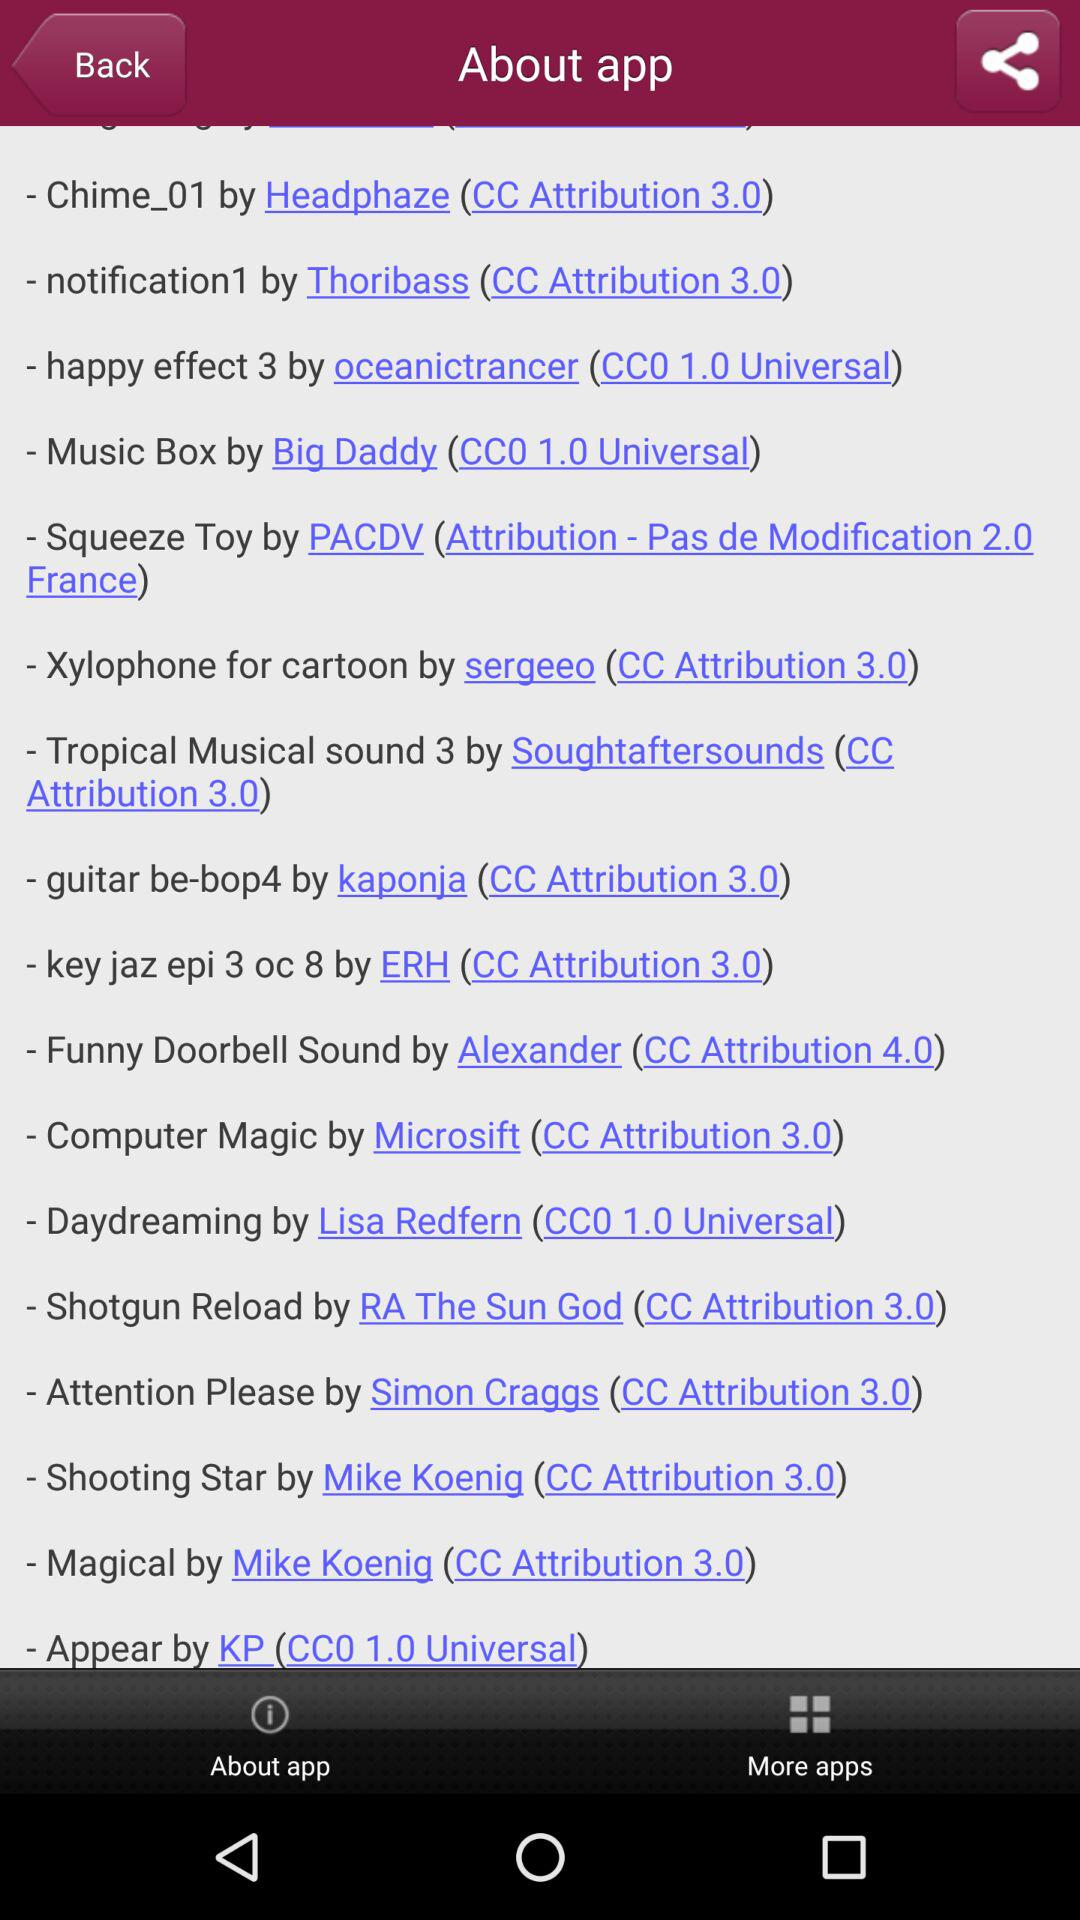Who created "Magical"? "Magical" was created by Mike Koenig. 